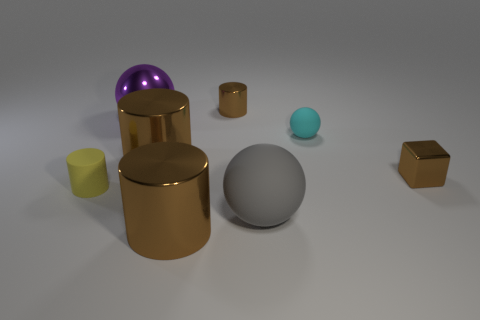There is a shiny cube that is the same color as the small metal cylinder; what size is it? small 